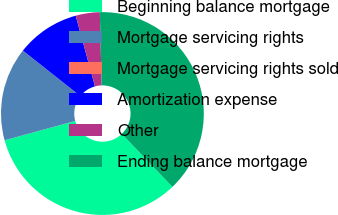<chart> <loc_0><loc_0><loc_500><loc_500><pie_chart><fcel>Beginning balance mortgage<fcel>Mortgage servicing rights<fcel>Mortgage servicing rights sold<fcel>Amortization expense<fcel>Other<fcel>Ending balance mortgage<nl><fcel>32.88%<fcel>14.89%<fcel>0.01%<fcel>10.11%<fcel>3.83%<fcel>38.28%<nl></chart> 